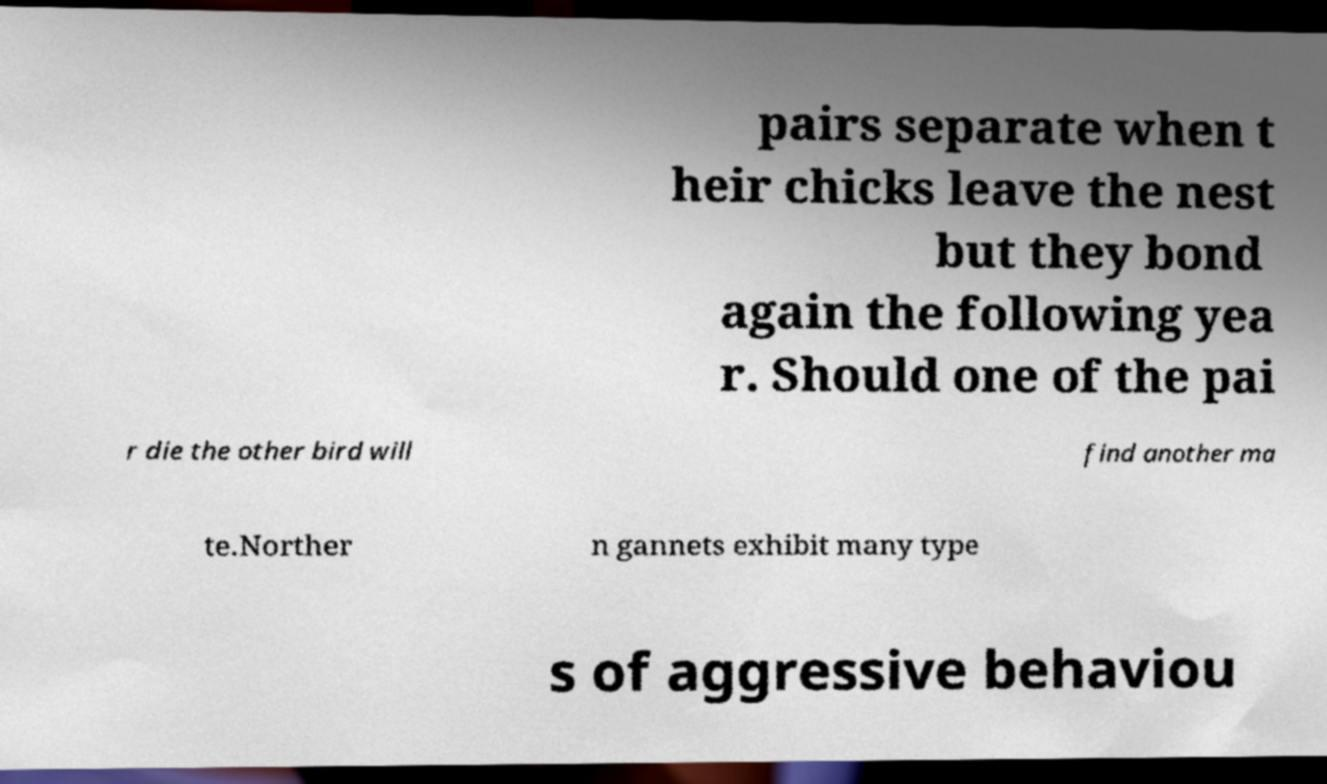There's text embedded in this image that I need extracted. Can you transcribe it verbatim? pairs separate when t heir chicks leave the nest but they bond again the following yea r. Should one of the pai r die the other bird will find another ma te.Norther n gannets exhibit many type s of aggressive behaviou 